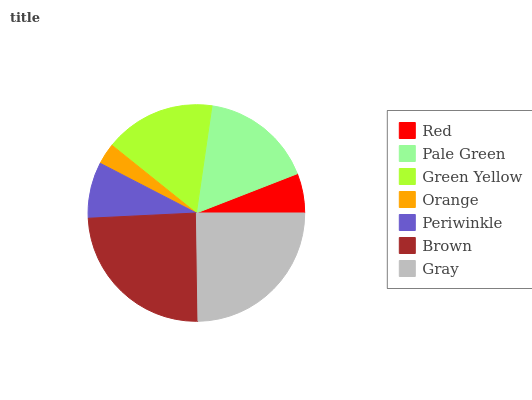Is Orange the minimum?
Answer yes or no. Yes. Is Gray the maximum?
Answer yes or no. Yes. Is Pale Green the minimum?
Answer yes or no. No. Is Pale Green the maximum?
Answer yes or no. No. Is Pale Green greater than Red?
Answer yes or no. Yes. Is Red less than Pale Green?
Answer yes or no. Yes. Is Red greater than Pale Green?
Answer yes or no. No. Is Pale Green less than Red?
Answer yes or no. No. Is Green Yellow the high median?
Answer yes or no. Yes. Is Green Yellow the low median?
Answer yes or no. Yes. Is Gray the high median?
Answer yes or no. No. Is Orange the low median?
Answer yes or no. No. 